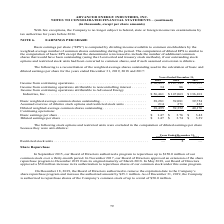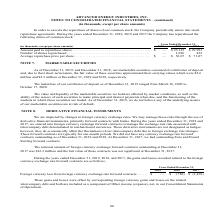From Advanced Energy's financial document, What are the years included in the table? The document contains multiple relevant values: 2019, 2018, 2017. From the document: "in thousands, except per share amounts) 2019 2018 2017 mber 31, (in thousands, except per share amounts) 2019 2018 2017 31, (in thousands, except per ..." Also, What was the number of shares repurchased in 2017? According to the financial document, 422 (in thousands). The relevant text states: "Number of shares repurchased . — 1,696 422 Average repurchase price per share . $ — $ 56.07 $ 71.07..." Also, What was the average repurchase price per share in 2018? According to the financial document, $56.07. The relevant text states: "96 422 Average repurchase price per share . $ — $ 56.07 $ 71.07..." Also, can you calculate: What was the change in Amount paid to repurchase shares between 2017 and 2018? Based on the calculation: $95,125-$29,993, the result is 65132 (in thousands). This is based on the information: "Amount paid to repurchase shares . $ — $ 95,125 $ 29,993 Amount paid to repurchase shares . $ — $ 95,125 $ 29,993..." The key data points involved are: 29,993, 95,125. Also, can you calculate: What was the change in number of shares repurchased between 2017 and 2018? Based on the calculation: 1,696-422, the result is 1274 (in thousands). This is based on the information: "Number of shares repurchased . — 1,696 422 Average repurchase price per share . $ — $ 56.07 $ 71.07 Number of shares repurchased . — 1,696 422 Average repurchase price per share . $ — $ 56.07 $ 71.07..." The key data points involved are: 1,696, 422. Also, can you calculate: What was the percentage change in the average repurchase price per share between 2017 and 2018? To answer this question, I need to perform calculations using the financial data. The calculation is: ($56.07-$71.07)/$71.07, which equals -21.11 (percentage). This is based on the information: "verage repurchase price per share . $ — $ 56.07 $ 71.07 96 422 Average repurchase price per share . $ — $ 56.07 $ 71.07..." The key data points involved are: 56.07, 71.07. 